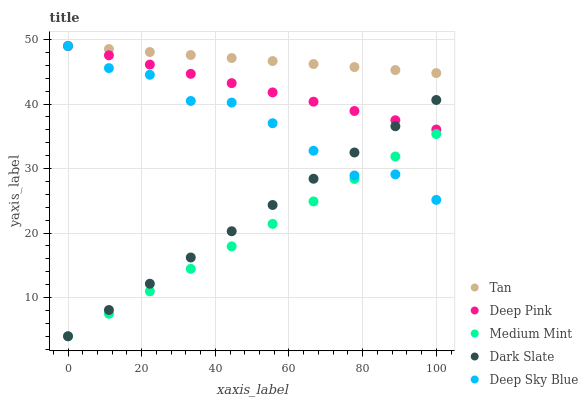Does Medium Mint have the minimum area under the curve?
Answer yes or no. Yes. Does Tan have the maximum area under the curve?
Answer yes or no. Yes. Does Dark Slate have the minimum area under the curve?
Answer yes or no. No. Does Dark Slate have the maximum area under the curve?
Answer yes or no. No. Is Deep Pink the smoothest?
Answer yes or no. Yes. Is Deep Sky Blue the roughest?
Answer yes or no. Yes. Is Dark Slate the smoothest?
Answer yes or no. No. Is Dark Slate the roughest?
Answer yes or no. No. Does Medium Mint have the lowest value?
Answer yes or no. Yes. Does Tan have the lowest value?
Answer yes or no. No. Does Deep Sky Blue have the highest value?
Answer yes or no. Yes. Does Dark Slate have the highest value?
Answer yes or no. No. Is Dark Slate less than Tan?
Answer yes or no. Yes. Is Tan greater than Dark Slate?
Answer yes or no. Yes. Does Deep Sky Blue intersect Dark Slate?
Answer yes or no. Yes. Is Deep Sky Blue less than Dark Slate?
Answer yes or no. No. Is Deep Sky Blue greater than Dark Slate?
Answer yes or no. No. Does Dark Slate intersect Tan?
Answer yes or no. No. 